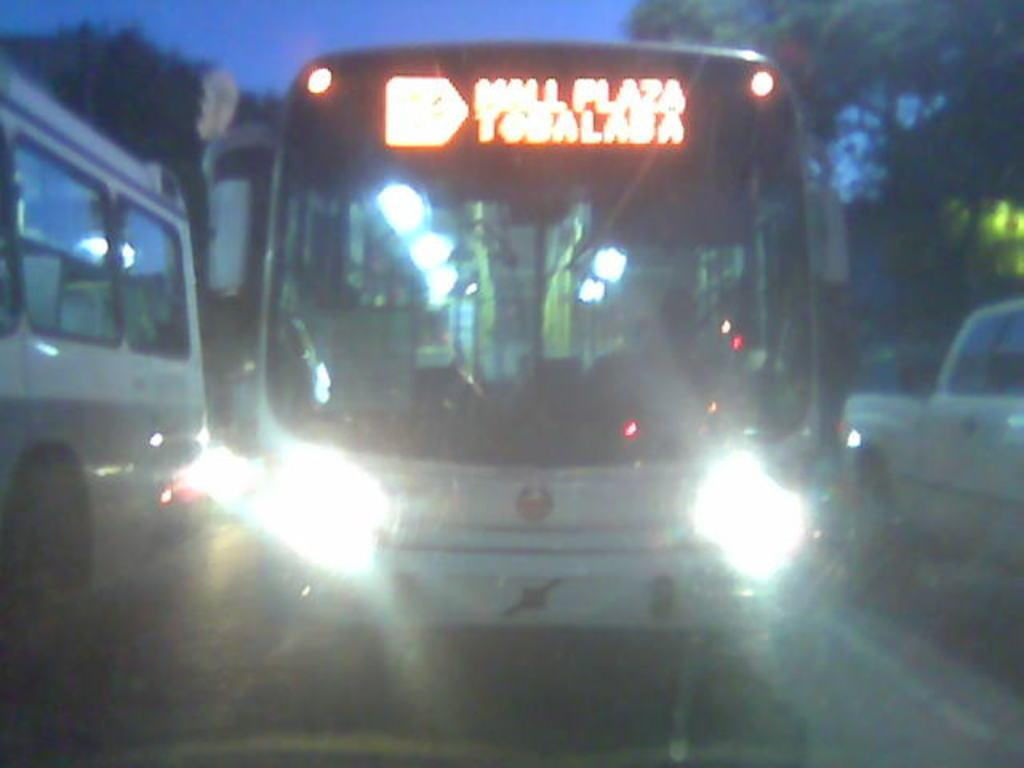What is the main subject in the center of the image? There is a bus in the center of the image. Can you describe the overall quality of the image? The image is blurred. What else can be seen on the road besides the bus? There are other vehicles visible on the road. What shape are the geese flying in the image? There are no geese present in the image. 